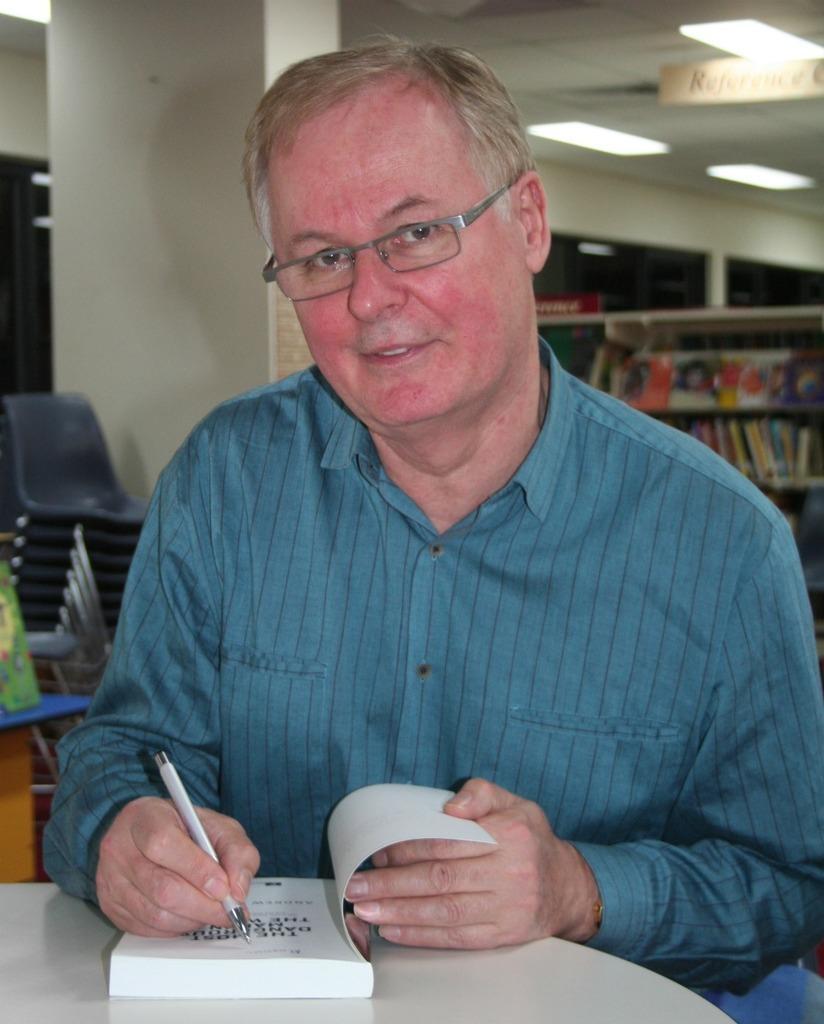In one or two sentences, can you explain what this image depicts? In this image we can see a man is writing on the book with a pen. Here we can see a table, chairs, pillar, racks, books, board, ceiling, and lights. 